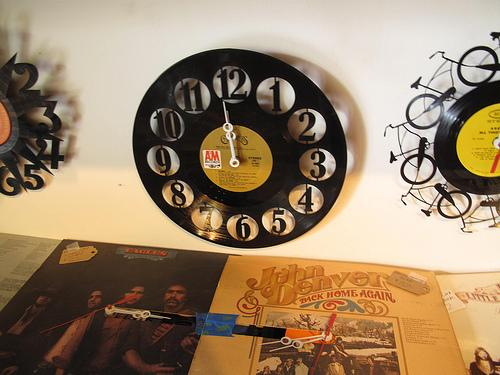Mention the central theme and elements of the image. The image revolves around artist-themed clocks, highlighting the Eagles and John Denver album covers, as well as a bicycle-inspired design, emphasizing hands, numbers, and other details. Explain the main objects in this picture and their unique features. The image showcases clocks made from vinyl records, each with different designs - Eagles album cover, John Denver's "Back Home Again" and a bicycle pattern cut out, all with distinctive hands and numbers. Describe the clocks in the image in the order they appear. The image displays a clock with the Eagles album cover, followed by John Denver's "Back Home Again" clock, and a third clock with a bicycle pattern all with distinct clock hands and numbers. Explain the primary concept of the image and its components. The image features the idea of repurposing album covers and designs into clocks, with examples such as the Eagles and John Denver's "Back Home Again," showcasing various details like hands, numbers, and unique cutouts. Provide a descriptive tour of the image, focusing on the clocks and their characteristics. The image takes us through an array of clocks featuring intricate album cover designs - the iconic Eagles, John Denver's "Back Home Again," and a unique bicycle-themed cutout clock - all adorned with distinct hands and numbers. Briefly describe the image, including details about the clocks. The image shows three distinctive clocks made from album covers, highlighting the Eagles, John Denver's "Back Home Again," and a bicycle-themed clock, all with detailed hands and numbers. Highlight the album-based themes of the clocks in the image. The image features clocks derived from music albums, including the Eagles, John Denver's "Back Home Again," and a unique bicycle-themed clock, all showcasing various details from their respective album designs. Give a brief overview of the items shown in the image. The image displays three clocks made from album covers, including one featuring the Eagles, John Denver, and a bicycle design, with various details such as hands and numbers. Narrate the image, focusing on the different types of clocks. There are three creative clocks on display, one illustrating the Eagles album cover, another with John Denver's "Back Home Again" cover, and a third featuring intricate bicycle-shaped cutouts. Illustrate the image by focusing on the clocks' artistic aspects. In the image, artistic clocks made from album covers, such as the Eagles and John Denver's "Back Home Again," are displayed, boasting intricate hands, numbers, and a distinct bicycle-shaped cutout design. 